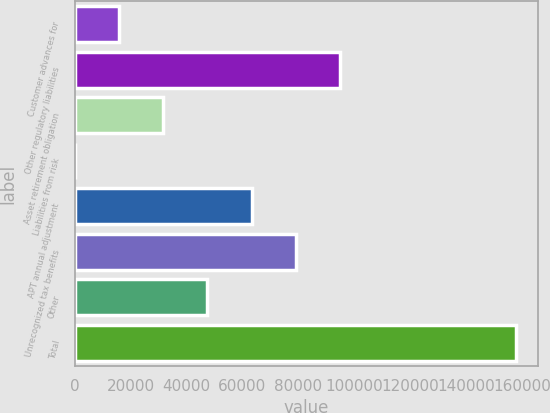Convert chart to OTSL. <chart><loc_0><loc_0><loc_500><loc_500><bar_chart><fcel>Customer advances for<fcel>Other regulatory liabilities<fcel>Asset retirement obligation<fcel>Liabilities from risk<fcel>APT annual adjustment<fcel>Unrecognized tax benefits<fcel>Other<fcel>Total<nl><fcel>15895.5<fcel>94858<fcel>31688<fcel>103<fcel>63273<fcel>79065.5<fcel>47480.5<fcel>158028<nl></chart> 